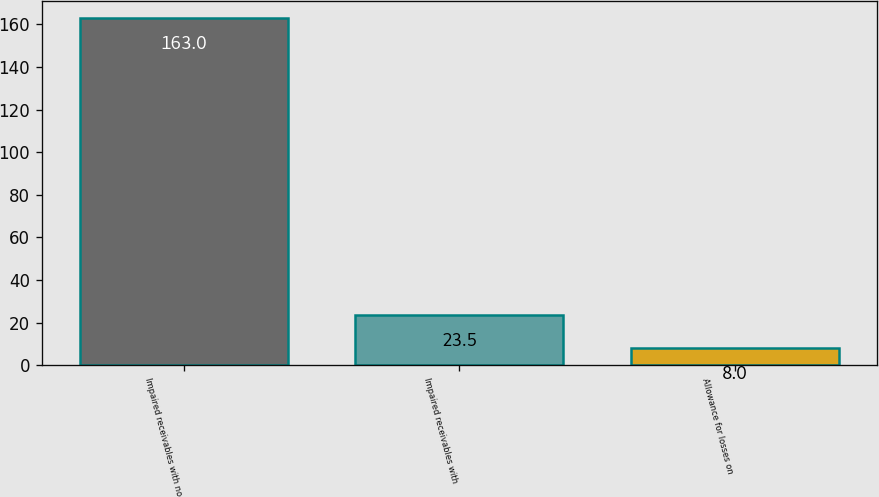Convert chart to OTSL. <chart><loc_0><loc_0><loc_500><loc_500><bar_chart><fcel>Impaired receivables with no<fcel>Impaired receivables with<fcel>Allowance for losses on<nl><fcel>163<fcel>23.5<fcel>8<nl></chart> 